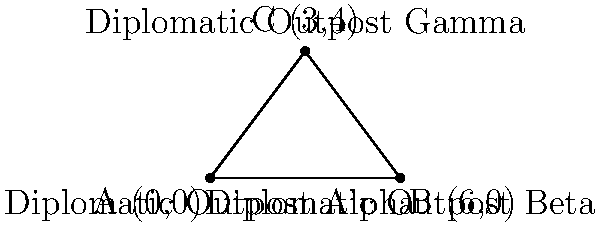In a remote region, three diplomatic outposts form a triangular area of strategic importance. Outpost Alpha is located at coordinates (0,0), Outpost Beta at (6,0), and Outpost Gamma at (3,4). Calculate the area of the triangular region formed by these outposts to determine the extent of the diplomatic zone. To find the area of the triangular region, we'll use the formula for the area of a triangle given the coordinates of its vertices:

Area = $\frac{1}{2}|x_1(y_2 - y_3) + x_2(y_3 - y_1) + x_3(y_1 - y_2)|$

Where $(x_1, y_1)$, $(x_2, y_2)$, and $(x_3, y_3)$ are the coordinates of the three vertices.

Let's substitute the given coordinates:
$(x_1, y_1) = (0, 0)$ (Outpost Alpha)
$(x_2, y_2) = (6, 0)$ (Outpost Beta)
$(x_3, y_3) = (3, 4)$ (Outpost Gamma)

Now, let's calculate:

Area = $\frac{1}{2}|0(0 - 4) + 6(4 - 0) + 3(0 - 0)|$
    = $\frac{1}{2}|0 + 24 + 0|$
    = $\frac{1}{2}(24)$
    = $12$

Therefore, the area of the triangular region formed by the three diplomatic outposts is 12 square units.
Answer: 12 square units 